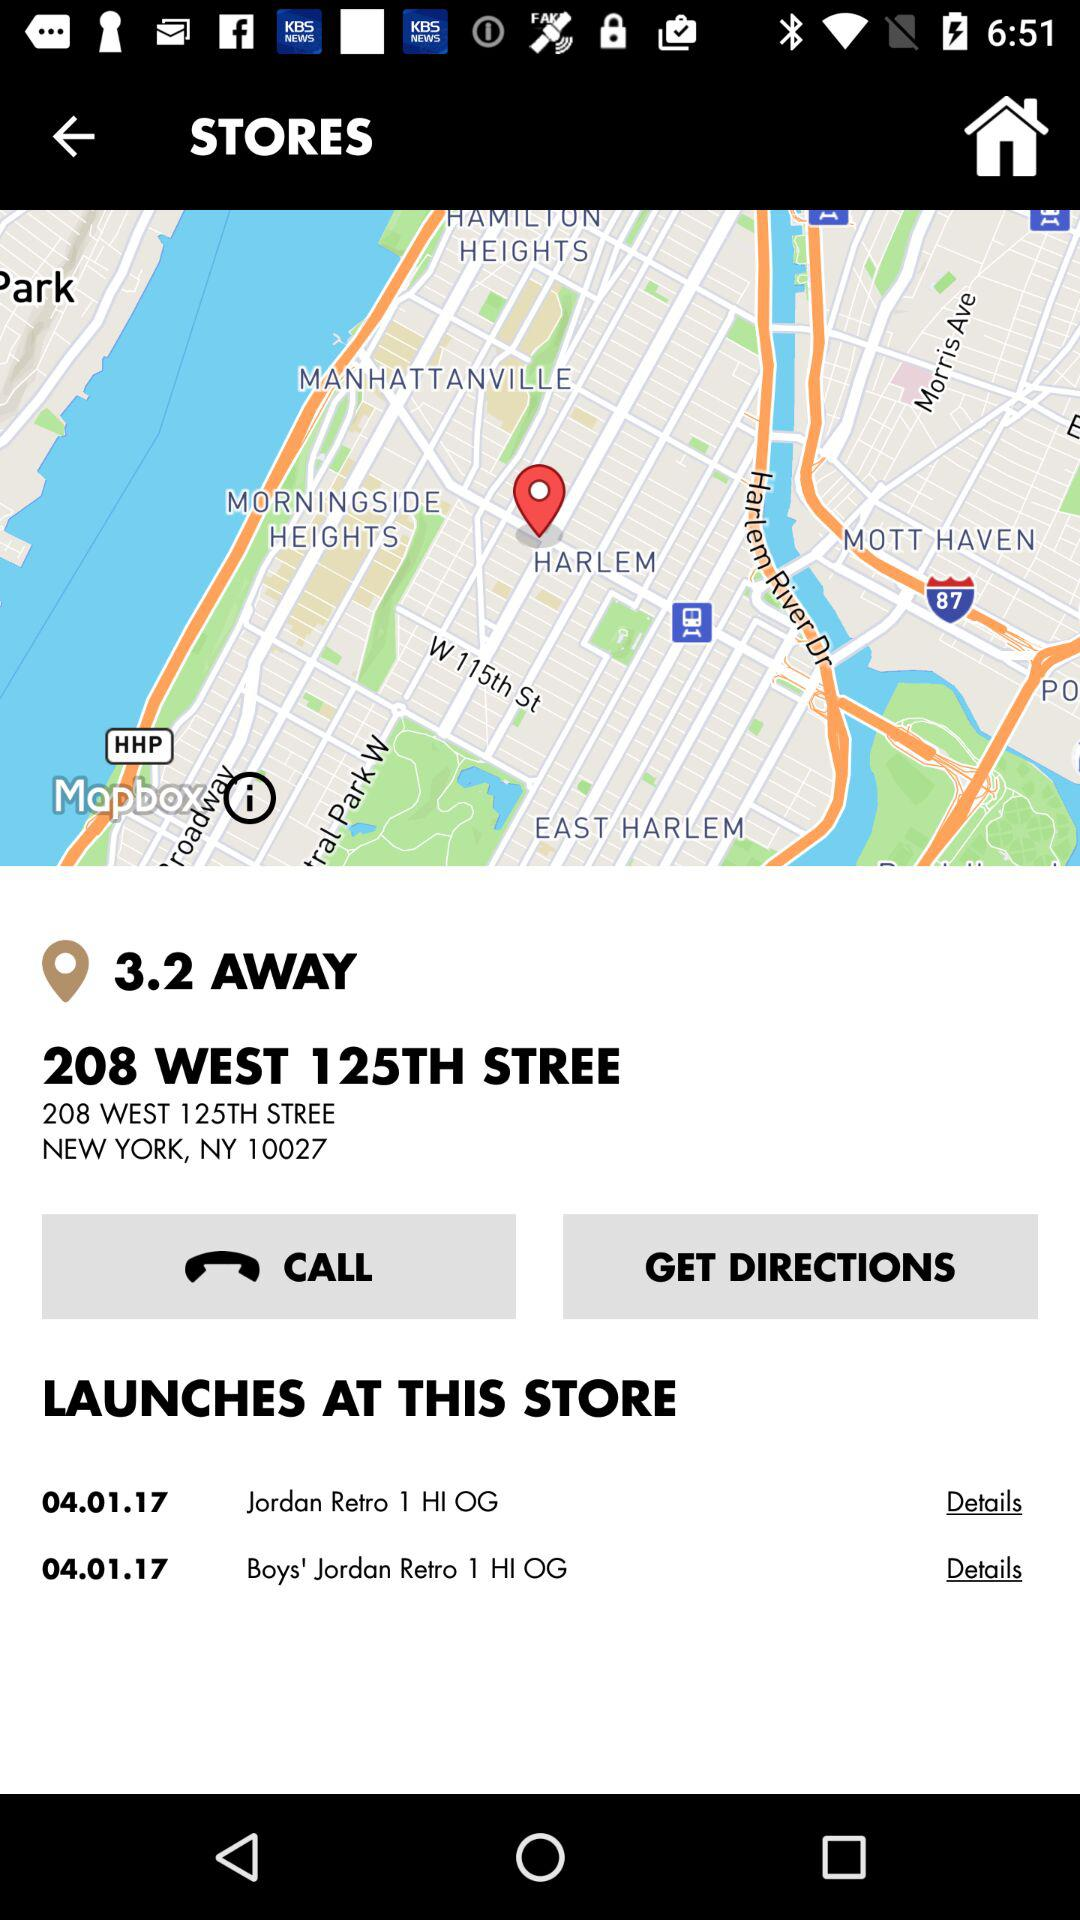What is the name of the store?
When the provided information is insufficient, respond with <no answer>. <no answer> 